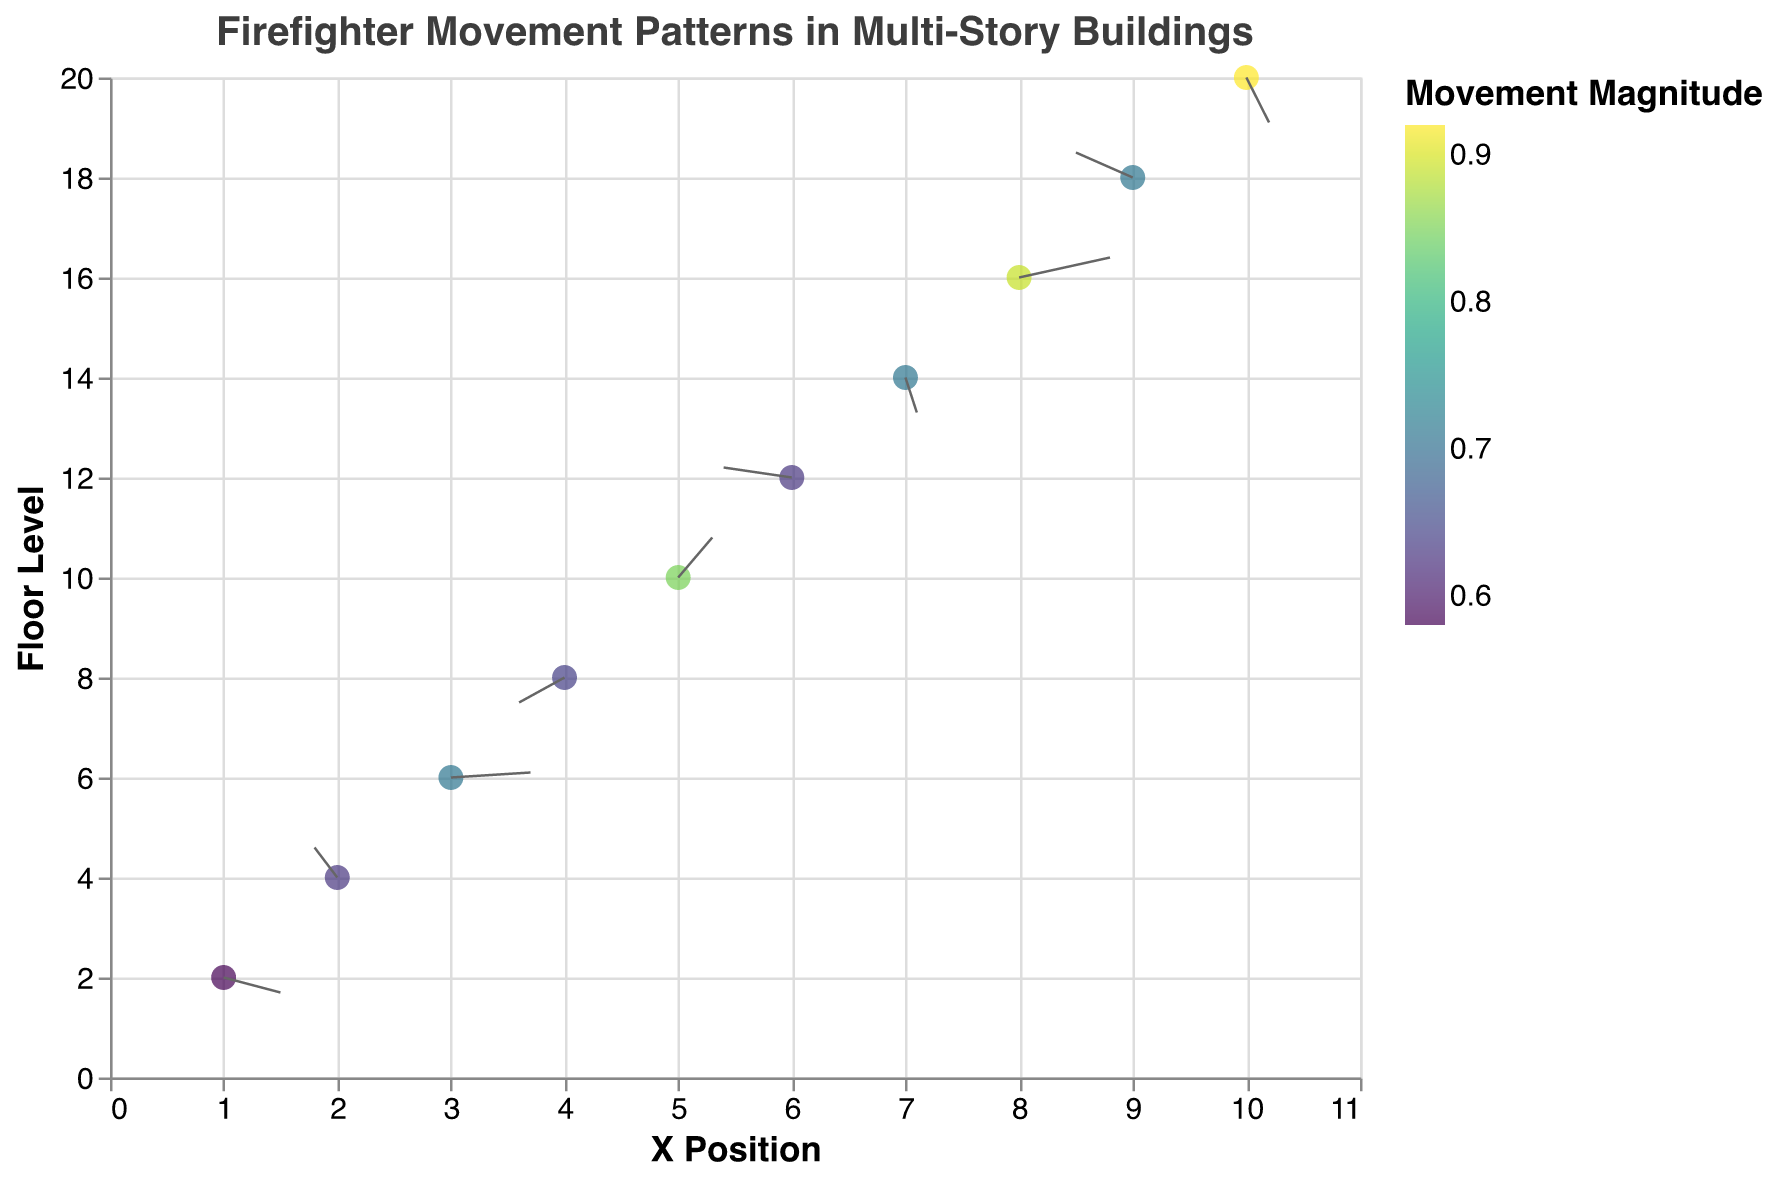What is the title of the figure? The text prominently displayed at the top of the figure informs us of its title. It reads "Firefighter Movement Patterns in Multi-Story Buildings".
Answer: Firefighter Movement Patterns in Multi-Story Buildings How many data points are shown in the figure? Each data point represents a different location and floor, visually evident from the distinct points on the plot. Counting these points shows there are 10 data points.
Answer: 10 Which data point has the highest movement magnitude? By looking at the color intensity of the points, the most vibrant (darkest) color corresponds to the highest movement magnitude. The most intense color appears at the X=10, Y=20 position, indicating the Tenth Floor Rooftop has the highest magnitude of 0.92.
Answer: Tenth Floor Rooftop Which location has the largest upward movement? The largest upward movement can be determined by the longest vector (arrow) pointing upwards. The Fifth Floor Office at X=5, Y=10 shows the largest upward vector with components (u=0.3, v=0.8).
Answer: Fifth Floor Office Which location shows a downward movement? Downward movement corresponds to vectors with negative 'v' components. Locations such as X=1,Y=2 (Lobby), X=7,Y=14 (Seventh Floor Balcony), and X=10,Y=20 (Tenth Floor Rooftop) show downward movement vectors.
Answer: Lobby, Seventh Floor Balcony, Tenth Floor Rooftop What is the average movement magnitude across all data points? To find the average magnitude, sum all the magnitudes and divide by the number of points. Summing 0.58, 0.63, 0.71, 0.64, 0.85, 0.63, 0.71, 0.89, 0.71, 0.92 gives 7.27. Dividing by 10 (number of points) results in 0.727.
Answer: 0.727 Which floor level shows the most horizontal movement? Horizontal movement is determined by the 'u' component. The highest absolute 'u' value is from the Sixth Floor Elevator with -0.6, implying notable horizontal movement on the sixth floor.
Answer: Sixth Floor Elevator How is the movement direction represented in the plot? Movement direction is represented by the orientation of arrows; right for positive 'u', left for negative 'u', up for positive 'v', and down for negative 'v'.
Answer: Arrows' orientation Which floors have vectors with both positive u and v components? Floors with positive 'u' and 'v' vectors can be identified as those where both components of the vector are greater than zero. The Third Floor Apartment (u=0.7, v=0.1), Fifth Floor Office (u=0.3, v=0.8), and Eighth Floor Penthouse (u=0.8, v=0.4) fit this criterion.
Answer: Third Floor Apartment, Fifth Floor Office, Eighth Floor Penthouse 